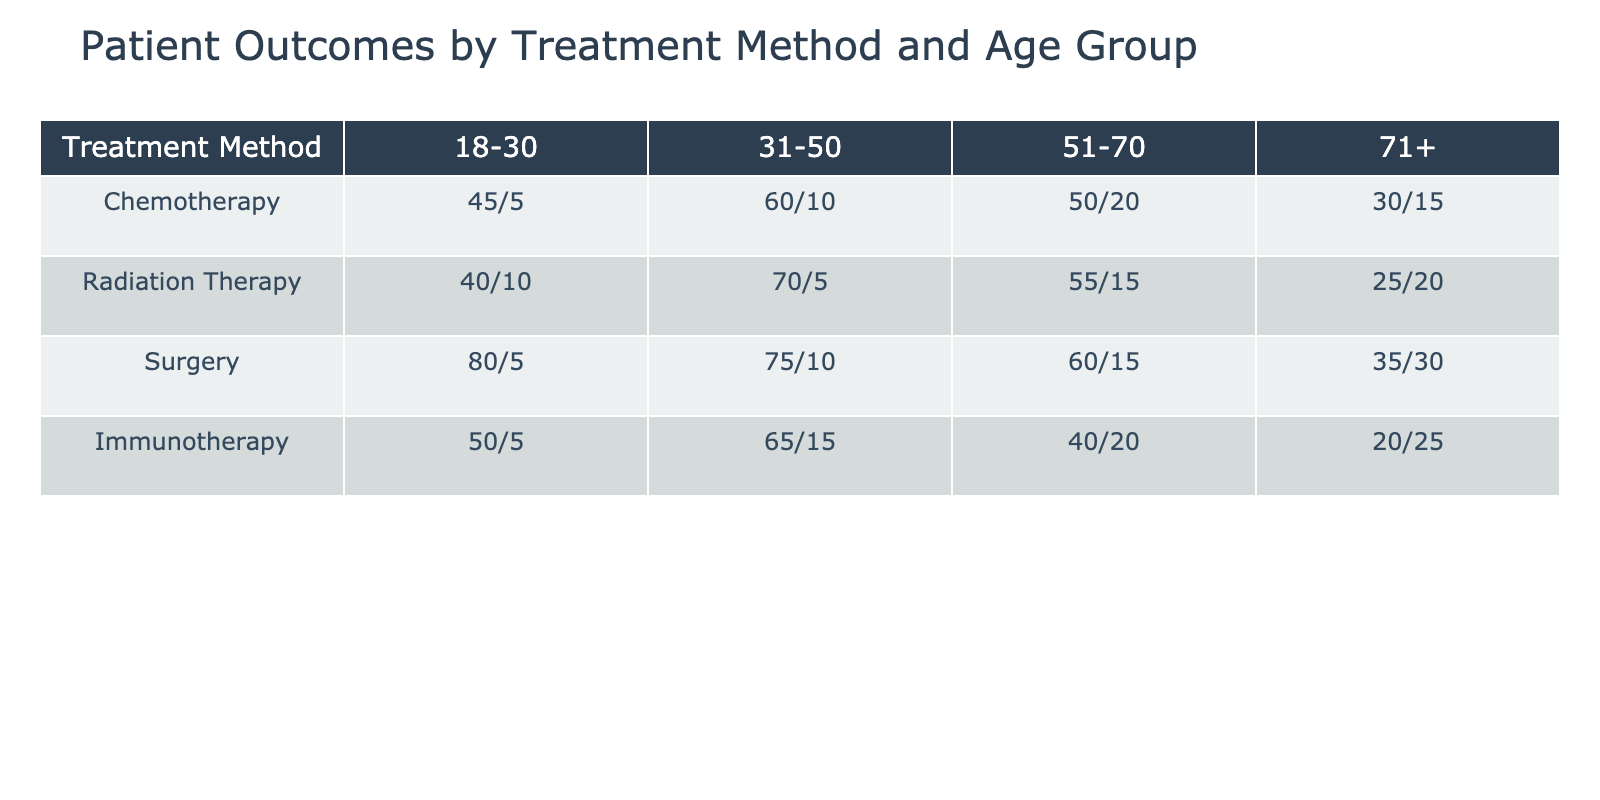What is the success rate for Surgery in the age group 31-50? The table shows that for the age group 31-50, Surgery has 75 successful outcomes and 10 unsuccessful outcomes. The success rate is calculated as successful outcomes divided by the total outcomes: (75 / (75 + 10)) = 75 / 85 = 0.8824. Therefore, the success rate is approximately 88.24%.
Answer: 88.24% Which treatment method has the highest number of unsuccessful outcomes in the age group 51-70? In the age group 51-70, the treatments and their unsuccessful outcomes are as follows: Chemotherapy has 20, Radiation Therapy has 15, Surgery has 15, and Immunotherapy has 20. The maximum value is 20, and both Chemotherapy and Immunotherapy have the highest number of unsuccessful outcomes.
Answer: Chemotherapy and Immunotherapy Is the success rate for Immunotherapy in the age group 71+ higher than for Radiation Therapy in the same age group? For Immunotherapy in the age group 71+, there are 20 successful outcomes and 25 unsuccessful outcomes, giving a success rate of (20 / (20 + 25)) = 20 / 45 ≈ 0.4444. For Radiation Therapy, there are 25 successful and 20 unsuccessful outcomes, providing a success rate of (25 / (25 + 20)) = 25 / 45 ≈ 0.5556. Since 0.4444 < 0.5556, Immunotherapy's success rate is lower than that of Radiation Therapy in the 71+ age group.
Answer: No What is the total number of successful outcomes across all treatment methods for patients aged 18-30? The successful outcomes for patients aged 18-30 by treatment method are: Chemotherapy has 45, Radiation Therapy has 40, Surgery has 80, and Immunotherapy has 50. Summing these gives 45 + 40 + 80 + 50 = 215 successful outcomes.
Answer: 215 